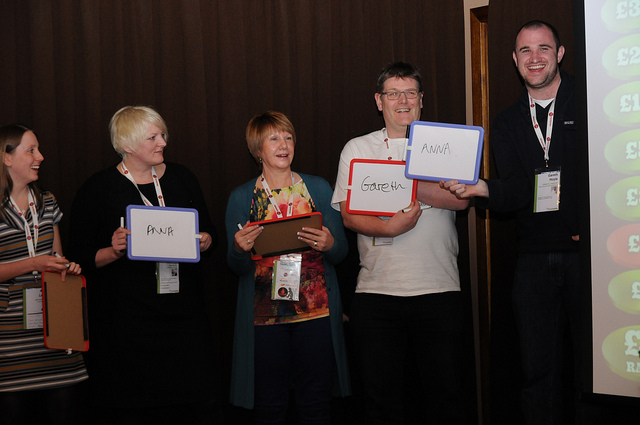Please extract the text content from this image. ANNA Gareth ANNA 